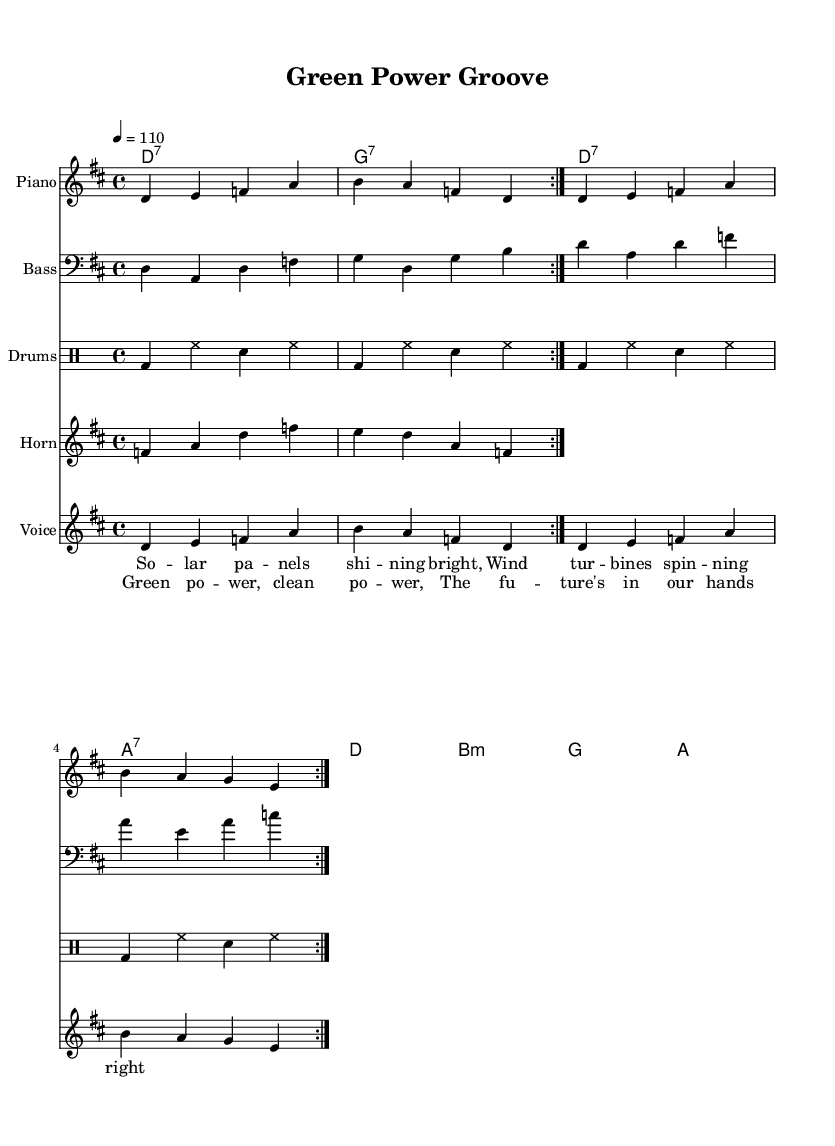What is the key signature of this music? The key signature is D major, which contains the two sharps (F# and C#). This is indicated at the beginning of the staff.
Answer: D major What is the time signature of this music? The time signature is 4/4, which indicates that there are four beats in each measure and a quarter note receives one beat. This can be seen in the notation at the beginning of the score.
Answer: 4/4 What is the tempo marking for this piece? The tempo is marked as 4 = 110, which indicates that there are 110 beats per minute (bpm). This is found at the beginning of the score with the tempo indication.
Answer: 110 How many times does the horn riff repeat? The horn riff is indicated to repeat twice as noted by the "repeat volta 2" command in the music. This dictates that the section should be played two times.
Answer: 2 What are the primary instruments used in this piece? The main instruments listed in the score are the electric piano, bass guitar, drums, and horns. Each instrument has its respective staff in the score with the instrument names clearly indicated.
Answer: Electric piano, bass guitar, drums, horns What is the lyrical theme of the chorus? The lyrics of the chorus highlight the themes of green energy and empowerment, as evidenced by the words "Green power, clean power, The future's in our hands." This reflects the overall upbeat funk-inspired R&B celebration of clean innovations.
Answer: Green power, clean power 